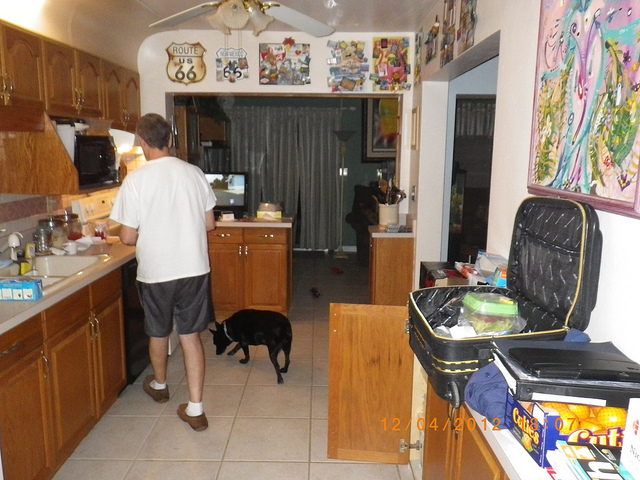Read all the text in this image. AOUTE 2012 04 07 